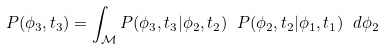Convert formula to latex. <formula><loc_0><loc_0><loc_500><loc_500>P ( \phi _ { 3 } , t _ { 3 } ) = \int _ { \mathcal { M } } P ( \phi _ { 3 } , t _ { 3 } | \phi _ { 2 } , t _ { 2 } ) \ P ( \phi _ { 2 } , t _ { 2 } | \phi _ { 1 } , t _ { 1 } ) \ d \phi _ { 2 }</formula> 